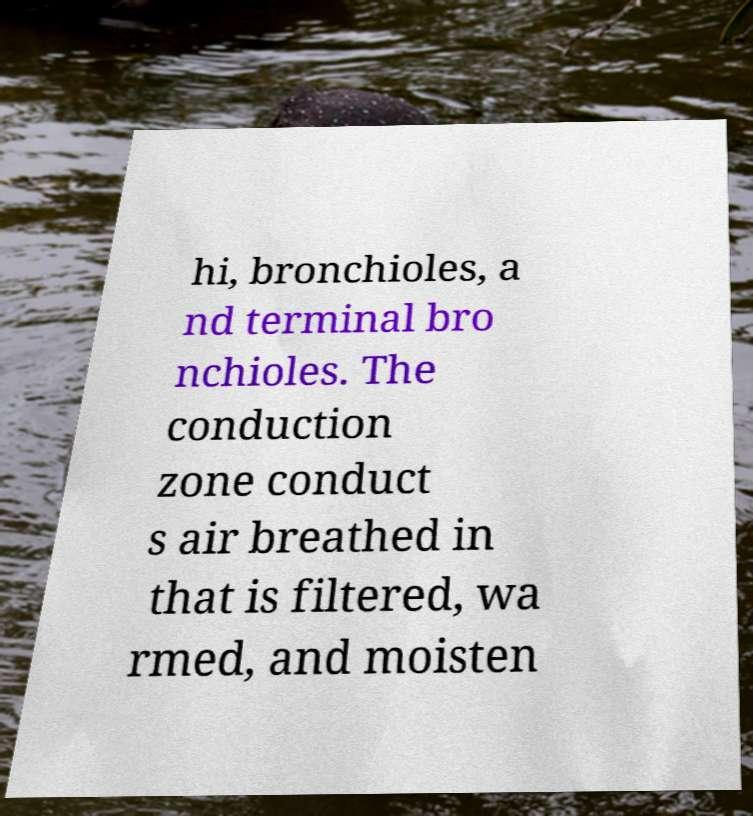Please identify and transcribe the text found in this image. hi, bronchioles, a nd terminal bro nchioles. The conduction zone conduct s air breathed in that is filtered, wa rmed, and moisten 